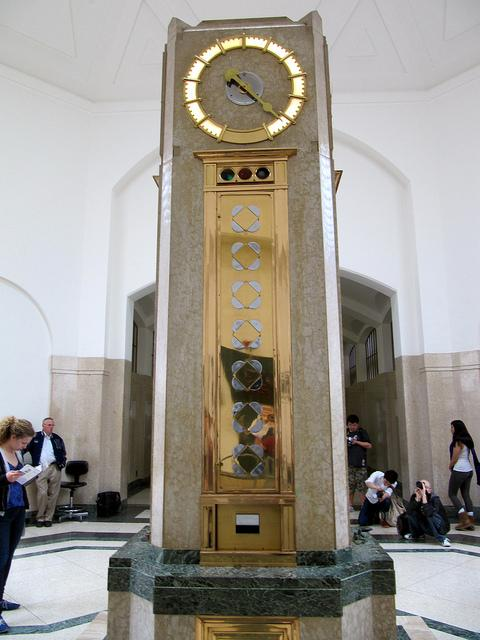The hand of the clock is closest to what number?

Choices:
A) twelve
B) nine
C) five
D) one five 